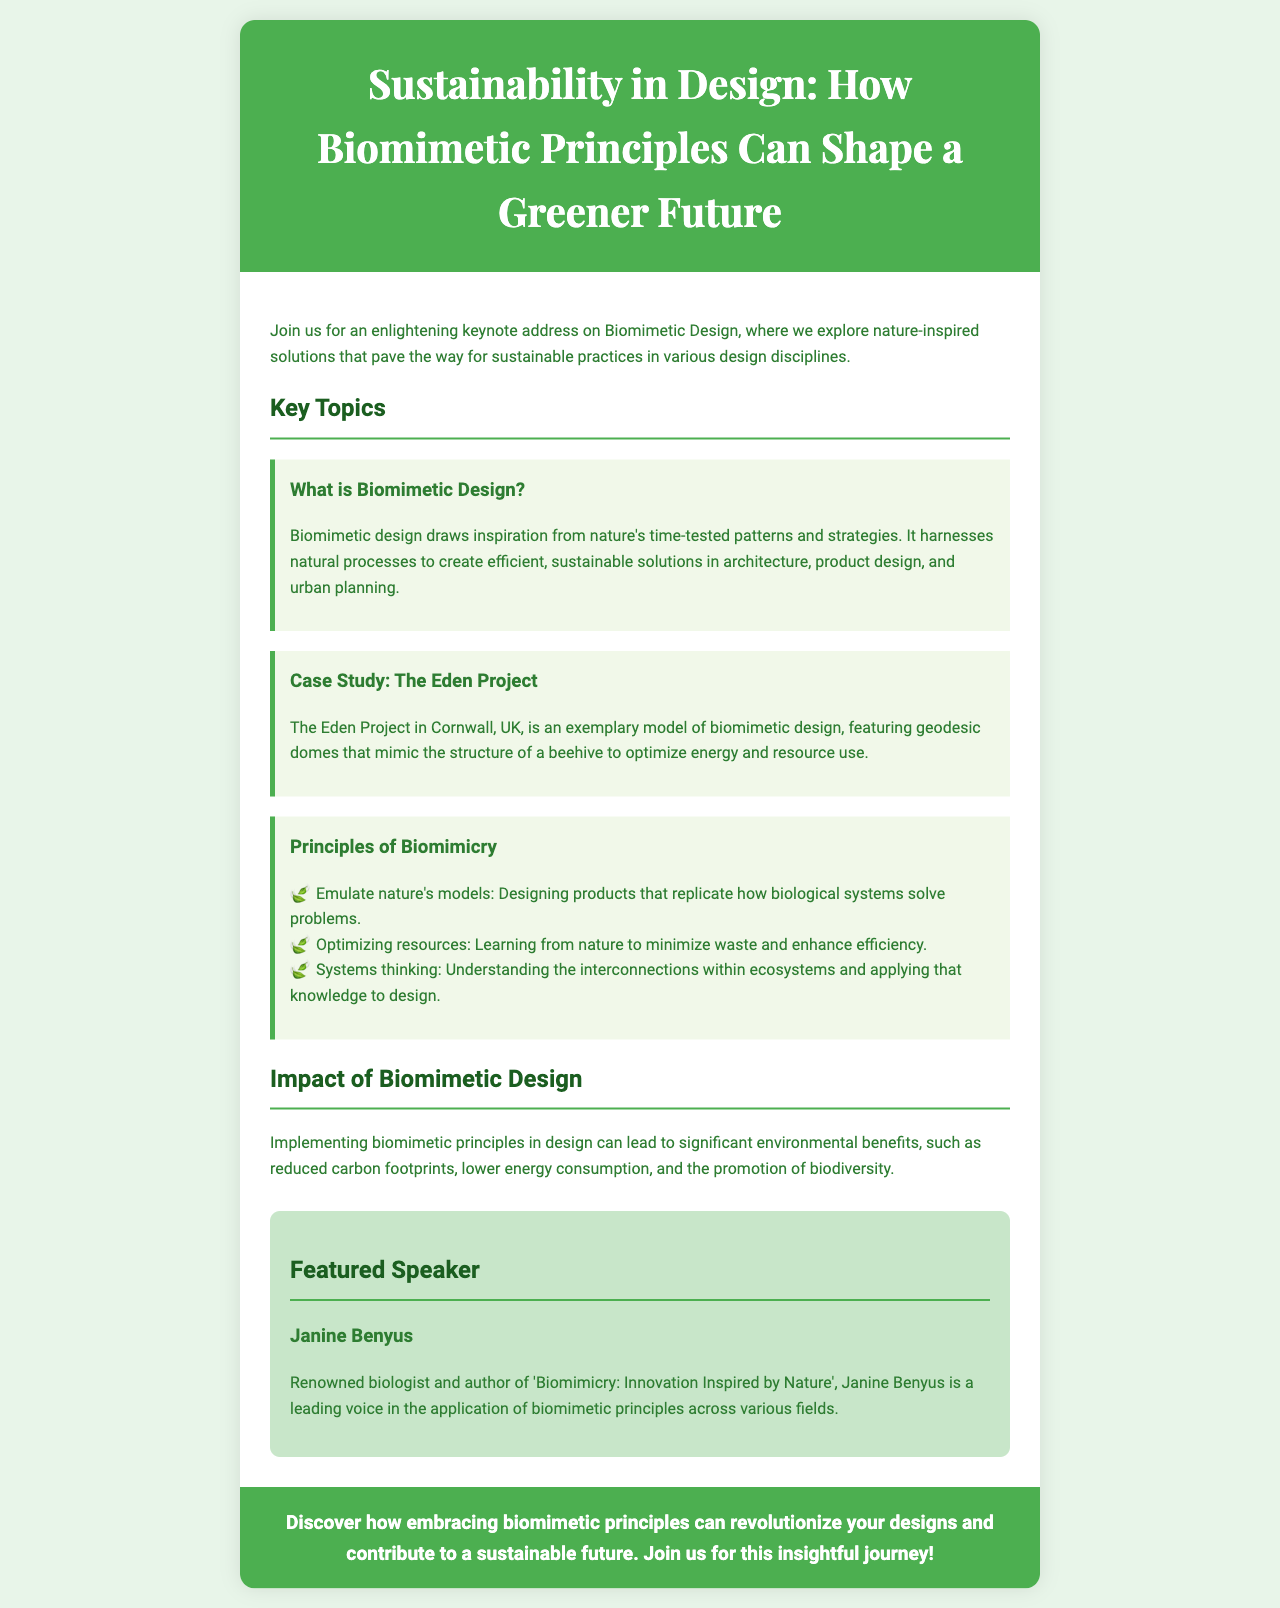What is the title of the keynote address? The title is explicitly mentioned at the top of the document.
Answer: Sustainability in Design: How Biomimetic Principles Can Shape a Greener Future Who is the featured speaker? The document introduces the featured speaker at the end of the content section.
Answer: Janine Benyus What is a case study mentioned in the document? The document provides a specific example of a case study under the relevant section.
Answer: The Eden Project What is one principle of biomimicry? The principles of biomimicry are listed in the document under key topics.
Answer: Emulate nature's models What type of environmental benefits can biomimetic design provide? The document specifies the impact under a dedicated section, mentioning a few benefits.
Answer: Reduced carbon footprints What does biomimetic design draw inspiration from? The document states what biomimetic design is derived from in its definition.
Answer: Nature's time-tested patterns and strategies In which country is The Eden Project located? The document mentions the location of The Eden Project within the case study.
Answer: UK What can embracing biomimetic principles revolutionize? The closing statement highlights the potential impact of these principles in design.
Answer: Your designs 